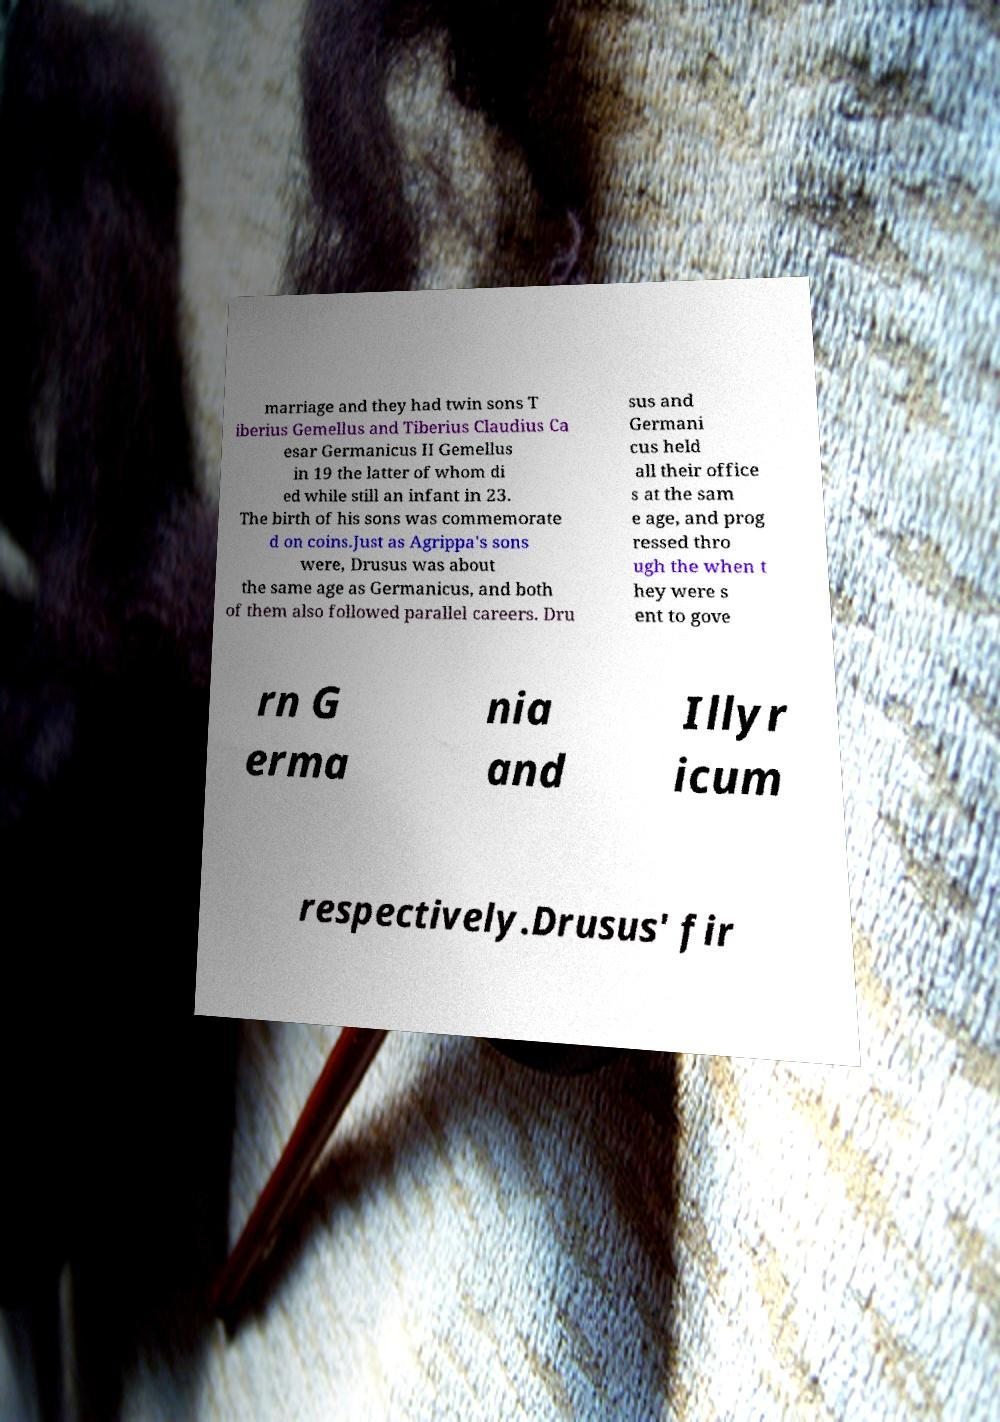Please identify and transcribe the text found in this image. marriage and they had twin sons T iberius Gemellus and Tiberius Claudius Ca esar Germanicus II Gemellus in 19 the latter of whom di ed while still an infant in 23. The birth of his sons was commemorate d on coins.Just as Agrippa's sons were, Drusus was about the same age as Germanicus, and both of them also followed parallel careers. Dru sus and Germani cus held all their office s at the sam e age, and prog ressed thro ugh the when t hey were s ent to gove rn G erma nia and Illyr icum respectively.Drusus' fir 